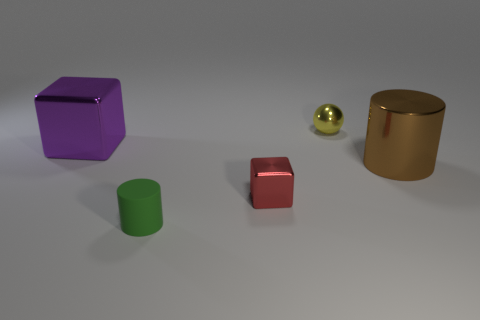What number of balls are there?
Ensure brevity in your answer.  1. How many things are small green cylinders or rubber things that are in front of the small yellow ball?
Keep it short and to the point. 1. Is there any other thing that is the same shape as the tiny red thing?
Provide a succinct answer. Yes. Is the size of the block in front of the purple block the same as the big purple thing?
Ensure brevity in your answer.  No. How many matte things are red blocks or red balls?
Your response must be concise. 0. What size is the cylinder left of the red metal block?
Offer a terse response. Small. Does the tiny yellow metallic thing have the same shape as the large purple shiny object?
Provide a short and direct response. No. How many small things are green rubber things or cubes?
Offer a very short reply. 2. There is a sphere; are there any shiny balls in front of it?
Make the answer very short. No. Is the number of things that are right of the large metallic cylinder the same as the number of big cyan rubber cylinders?
Your response must be concise. Yes. 